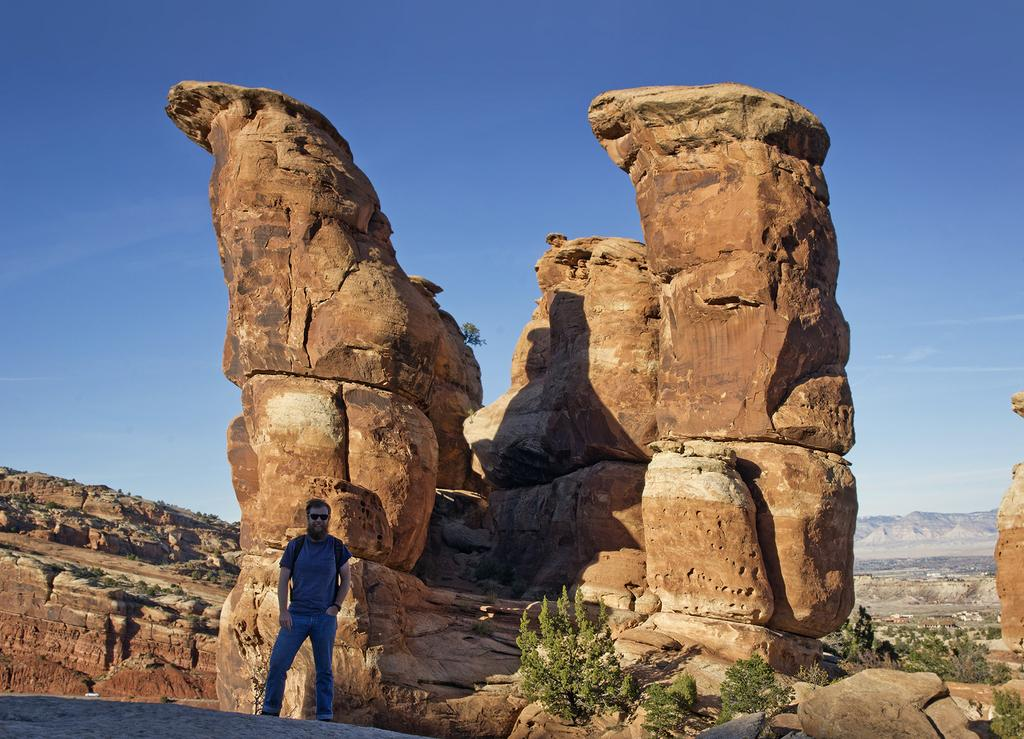What is the man in the image wearing on his upper body? The man is wearing a t-shirt. What is the man wearing on his lower body? The man is wearing trousers. What accessory is the man wearing in the image? The man is wearing spectacles. What can be seen behind the man in the image? There are big rocks behind the man. What type of vegetation is on the right side of the image? There are trees on the right side of the image. What is visible at the top of the image? The sky is visible at the top of the image. What type of cream is being served on the plate in the image? There is no plate or cream present in the image. 